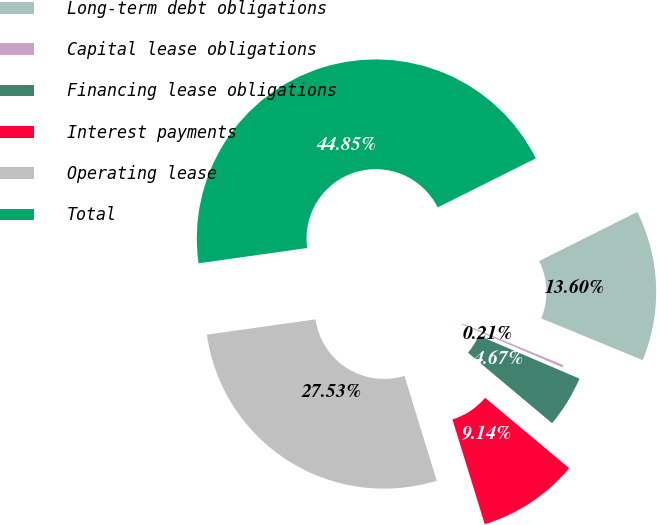Convert chart. <chart><loc_0><loc_0><loc_500><loc_500><pie_chart><fcel>Long-term debt obligations<fcel>Capital lease obligations<fcel>Financing lease obligations<fcel>Interest payments<fcel>Operating lease<fcel>Total<nl><fcel>13.6%<fcel>0.21%<fcel>4.67%<fcel>9.14%<fcel>27.53%<fcel>44.85%<nl></chart> 